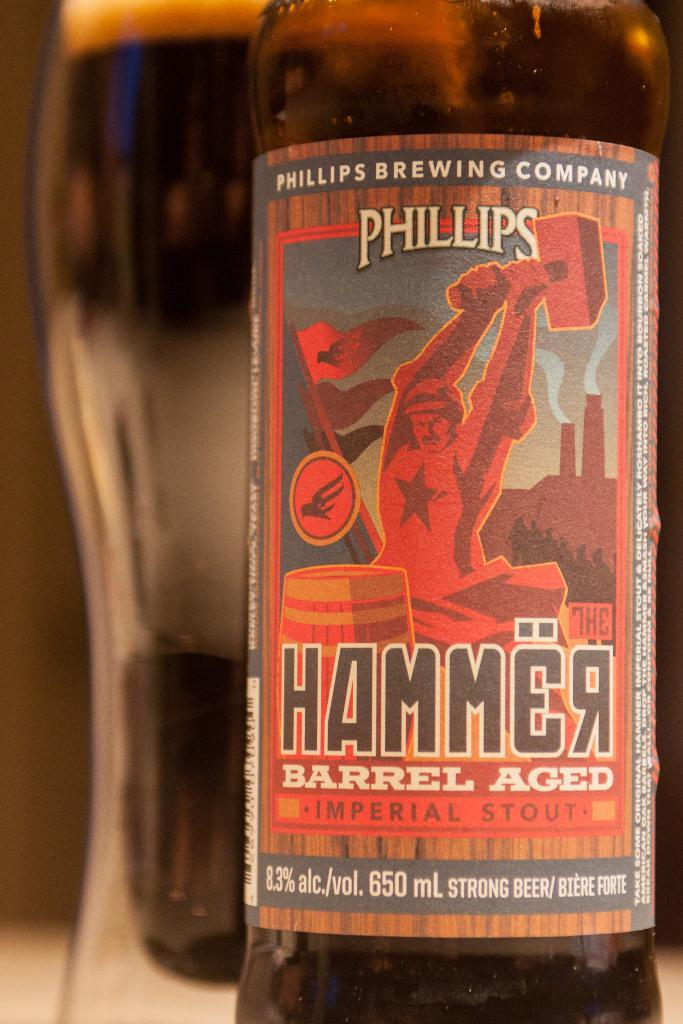Provide a one-sentence caption for the provided image. a close up of Phillips Hammer Barrel Aged Stout. 